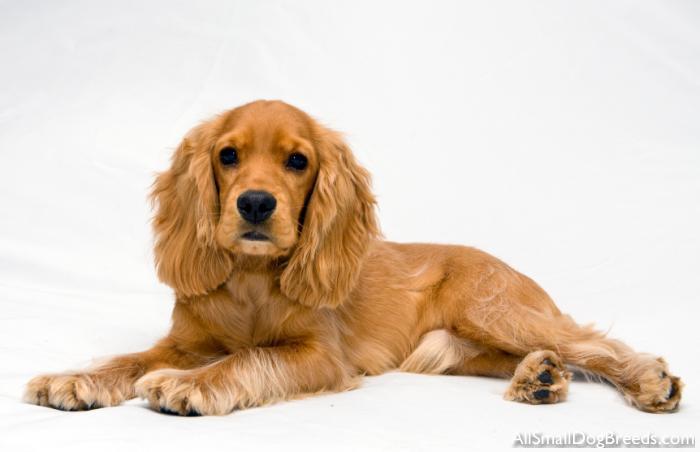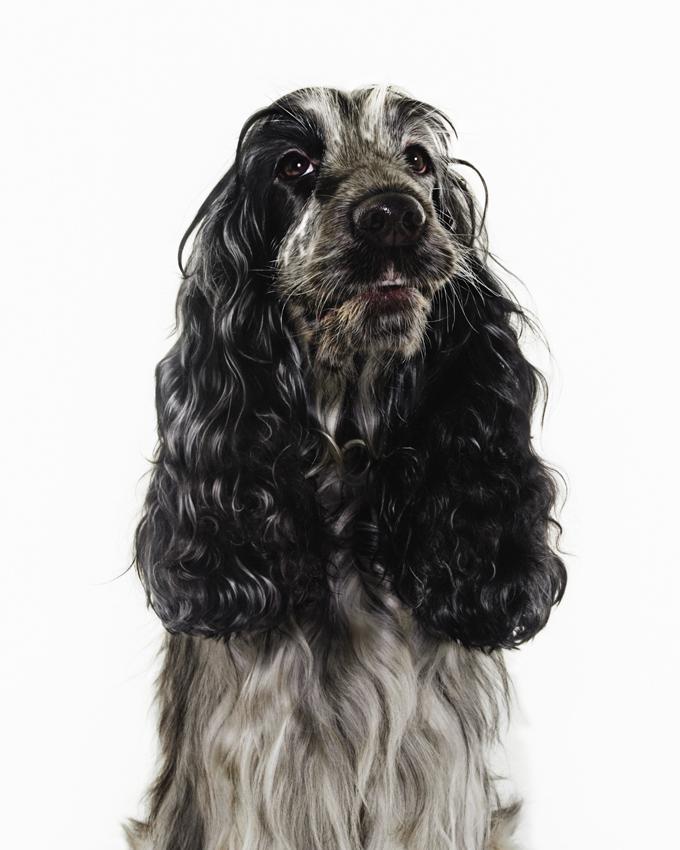The first image is the image on the left, the second image is the image on the right. For the images displayed, is the sentence "There are at most two dogs." factually correct? Answer yes or no. Yes. 